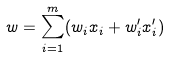<formula> <loc_0><loc_0><loc_500><loc_500>w = \sum _ { i = 1 } ^ { m } ( w _ { i } x _ { i } + w ^ { \prime } _ { i } x ^ { \prime } _ { i } )</formula> 